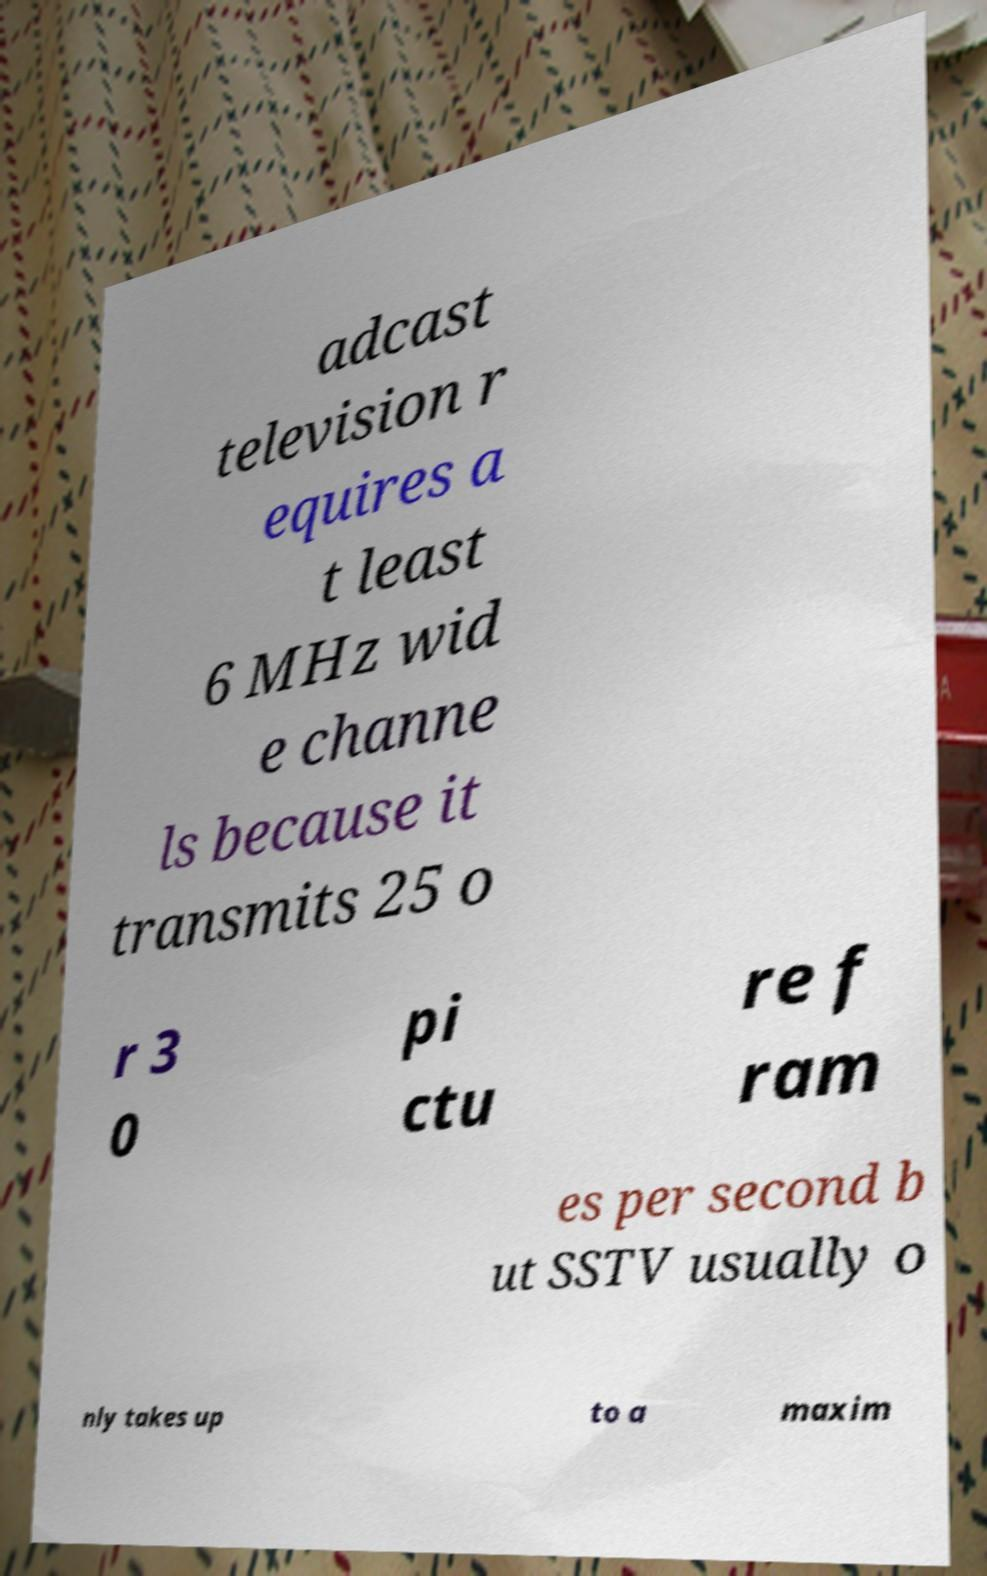Can you read and provide the text displayed in the image?This photo seems to have some interesting text. Can you extract and type it out for me? adcast television r equires a t least 6 MHz wid e channe ls because it transmits 25 o r 3 0 pi ctu re f ram es per second b ut SSTV usually o nly takes up to a maxim 